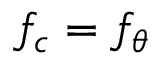<formula> <loc_0><loc_0><loc_500><loc_500>f _ { c } = f _ { \theta }</formula> 